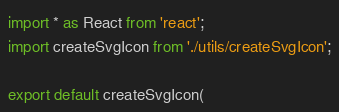Convert code to text. <code><loc_0><loc_0><loc_500><loc_500><_TypeScript_>import * as React from 'react';
import createSvgIcon from './utils/createSvgIcon';

export default createSvgIcon(</code> 